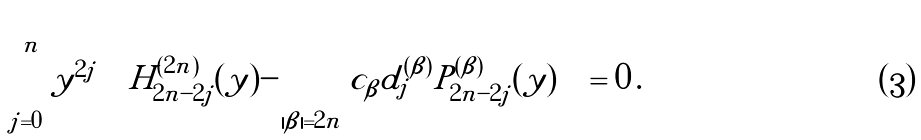<formula> <loc_0><loc_0><loc_500><loc_500>\sum _ { j = 0 } ^ { n } | y | ^ { 2 j } \left [ H ^ { ( 2 n ) } _ { 2 n - 2 j } ( y ) - \sum _ { | \beta | = 2 n } c _ { \beta } d _ { j } ^ { ( \beta ) } P _ { 2 n - 2 j } ^ { ( \beta ) } ( y ) \right ] = 0 \, .</formula> 